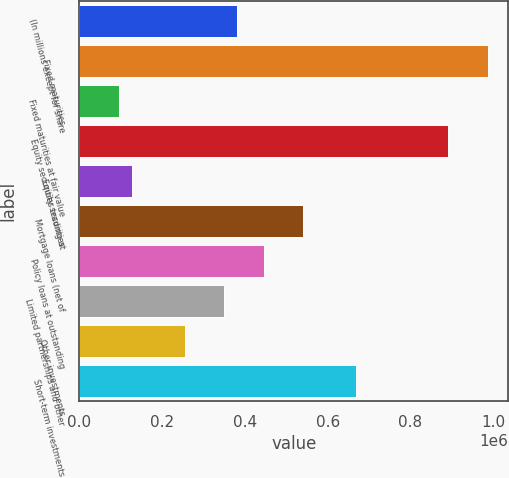Convert chart. <chart><loc_0><loc_0><loc_500><loc_500><bar_chart><fcel>(In millions except for share<fcel>Fixed maturities<fcel>Fixed maturities at fair value<fcel>Equity securities trading at<fcel>Equity securities<fcel>Mortgage loans (net of<fcel>Policy loans at outstanding<fcel>Limited partnerships and other<fcel>Other investments<fcel>Short-term investments<nl><fcel>382014<fcel>986862<fcel>95507.3<fcel>891360<fcel>127341<fcel>541185<fcel>445682<fcel>350180<fcel>254678<fcel>668521<nl></chart> 